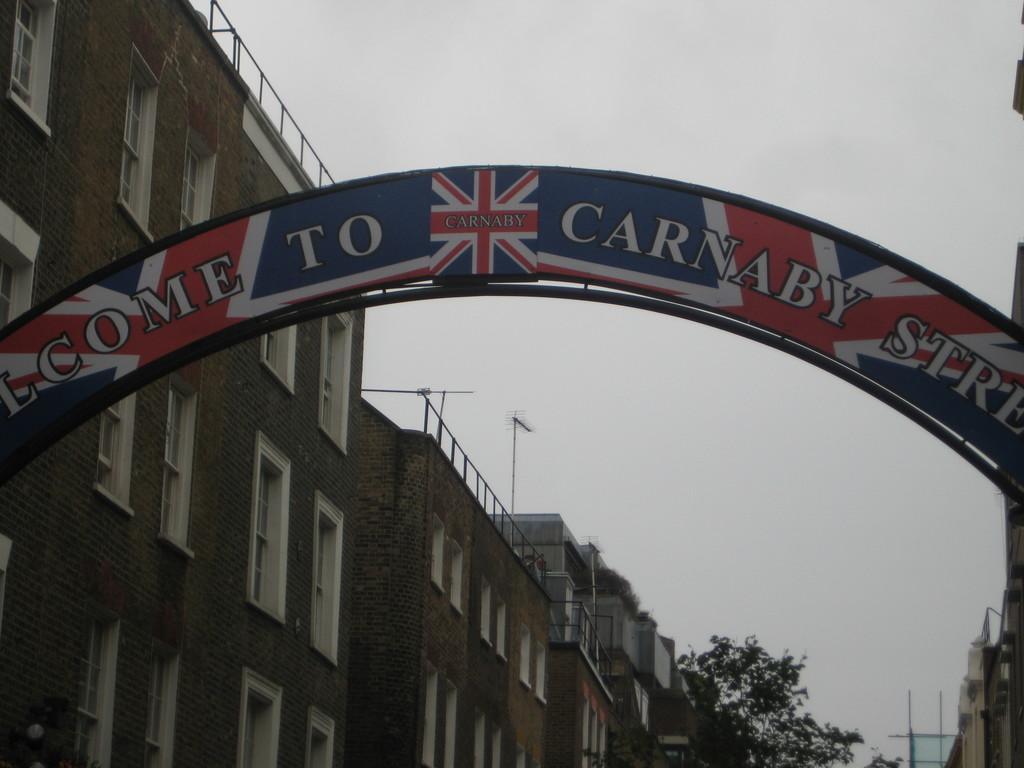Can you describe this image briefly? In this image I can see an arch which is red, blue and white in color. I can see few buildings on both side of the arch which are brown and white in color, few trees, few windows of the building. In the background I can see the sky. 